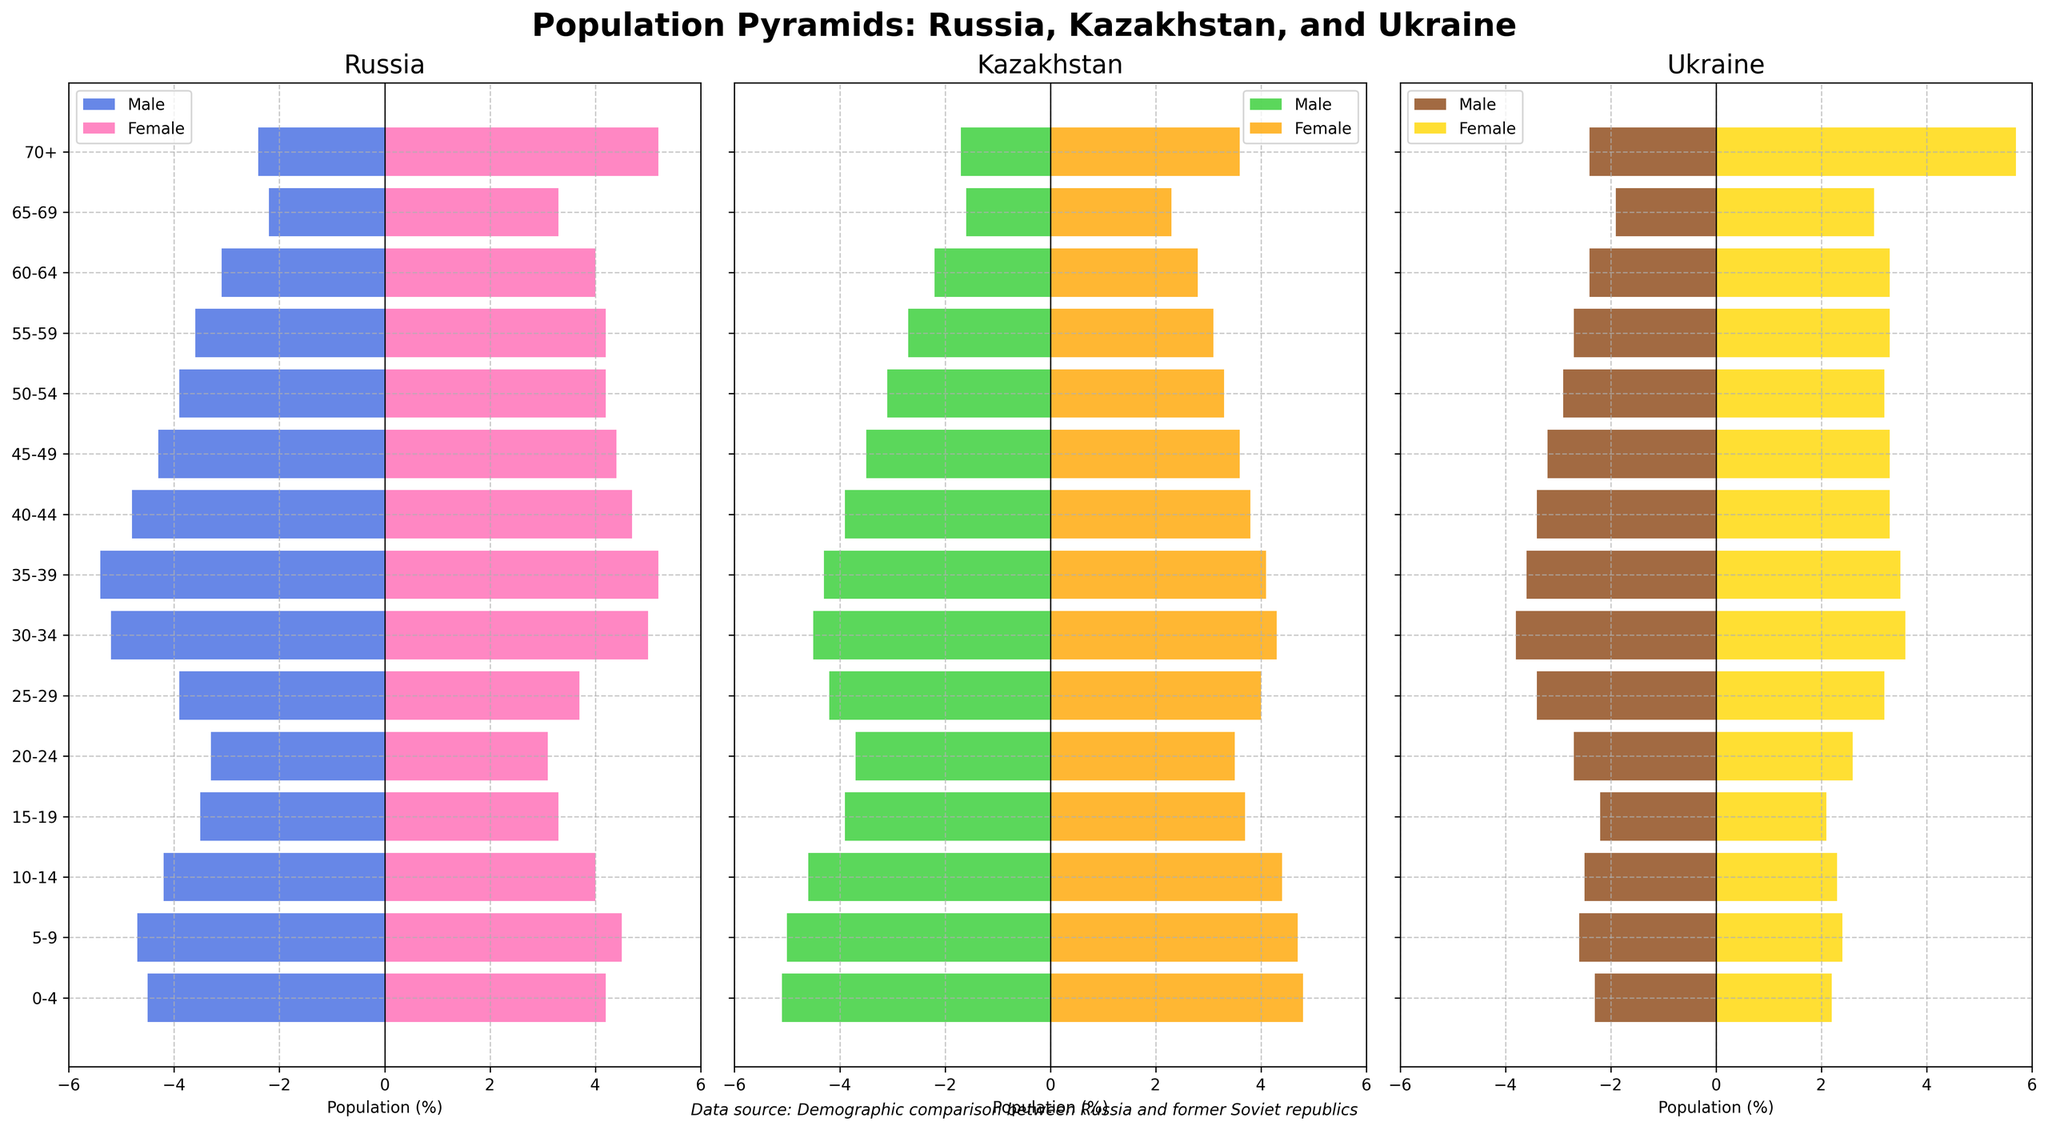What are the population percentages for males and females in the 0-4 age group in Russia? In the figure, observe the bars for the 0-4 age group in the Russia section. For males, it is 4.5%, and for females, it is 4.2%.
Answer: Males: 4.5%, Females: 4.2% Which country has the highest population percentage of males in the 30-34 age group? Compare the bars for males in the 30-34 age group across Russia, Kazakhstan, and Ukraine. Kazakhstan's bar is the highest at 4.5%.
Answer: Kazakhstan Does Ukraine have a higher population percentage of females aged 70+ compared to Russia? Compare the length of the bars representing females aged 70+ in Russia and Ukraine sections. Ukraine has a longer bar at 5.7% compared to Russia's 5.2%.
Answer: Yes Which age group in Russia shows the largest percentage difference between males and females, and what is that difference? For each age group in Russia, calculate the absolute difference between male and female percentages. The largest difference is in the 70+ age group with a difference of 2.8% (5.2% - 2.4%).
Answer: 70+, 2.8% What is the total population percentage of males aged 20-44 in Kazakhstan? Sum the percentages of males in the 20-24, 25-29, 30-34, 35-39, and 40-44 age groups in Kazakhstan. (-3.7) + (-4.2) + (-4.5) + (-4.3) + (-3.9) = -20.6%.
Answer: 20.6% How do the male population percentages in the 60-64 age group compare among Russia, Kazakhstan, and Ukraine? Compare the bars for males in the 60-64 age group across the three countries. Russia shows 3.1%, Kazakhstan has 2.2%, and Ukraine has 2.4%.
Answer: Russia: 3.1%, Kazakhstan: 2.2%, Ukraine: 2.4% In which country do females aged 55-59 have a higher percentage than males in the same age group? Check the bars for females and males aged 55-59 for each country. In Russia and Ukraine, females have higher percentages than males. In Kazakhstan, this is also true.
Answer: Russia, Kazakhstan, Ukraine Which gender and country have the highest population percentage among those aged 30-34? Compare the bars for males and females aged 30-34 in Russia, Kazakhstan, and Ukraine. Russia's females are the highest at 5.0%.
Answer: Russia females What is the average population percentage of females aged 10-14 in the three countries? Calculate the average by summing the percentages for females aged 10-14 in Russia, Kazakhstan, and Ukraine and then dividing by 3. (4.0 + 4.4 + 2.3) / 3 ≈ 3.57%.
Answer: 3.57% Do any age groups show a higher percentage of males than females in Ukraine? Compare the male and female bars for each age group in Ukraine. None of the age groups have a higher percentage of males than females.
Answer: No 